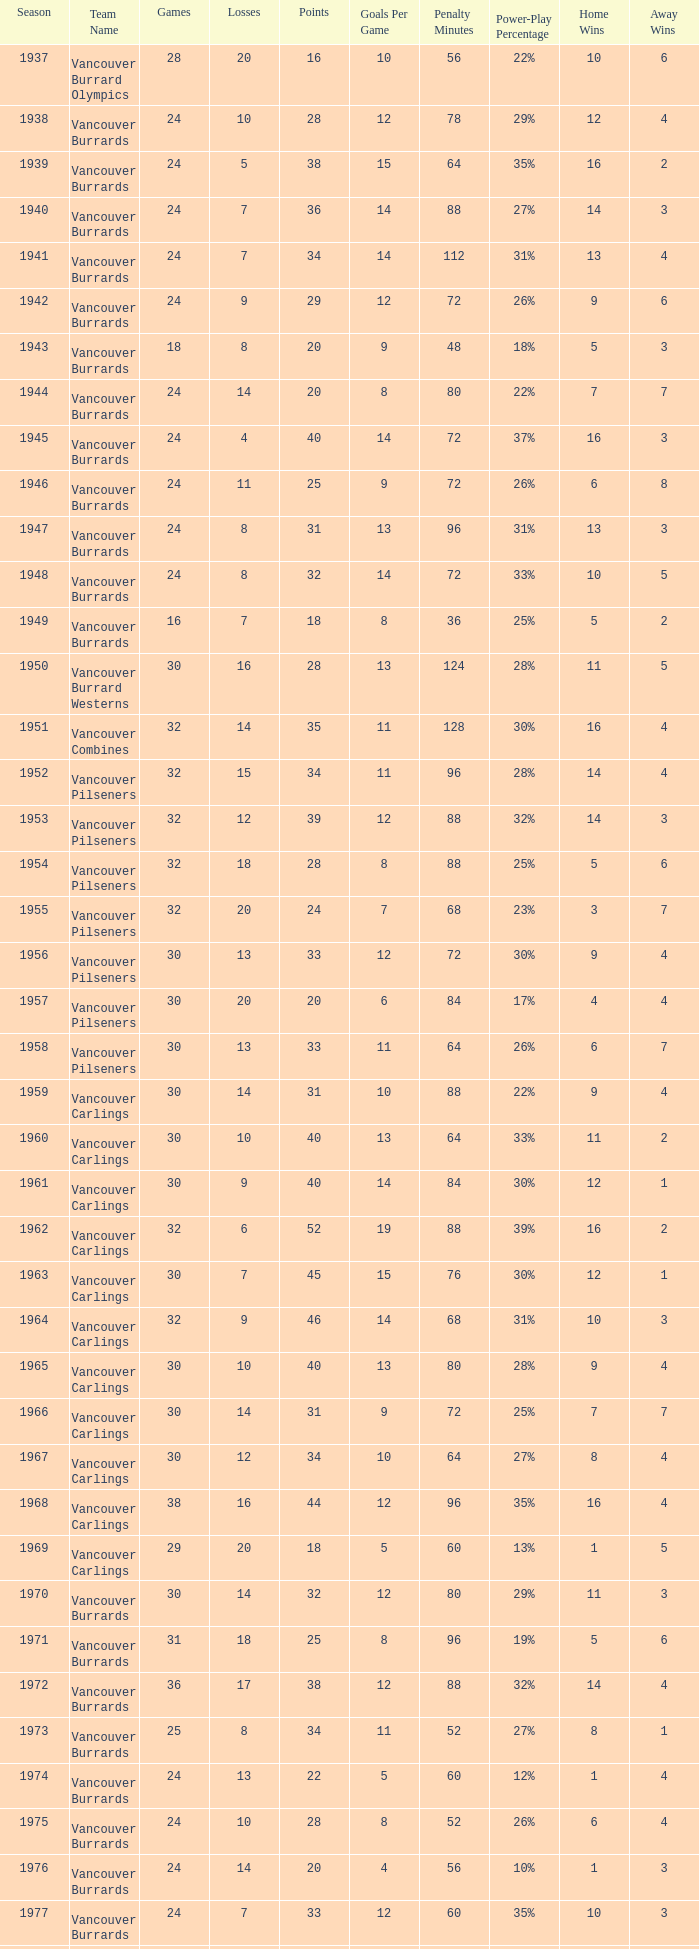What's the lowest number of points with fewer than 8 losses and fewer than 24 games for the vancouver burrards? 18.0. 